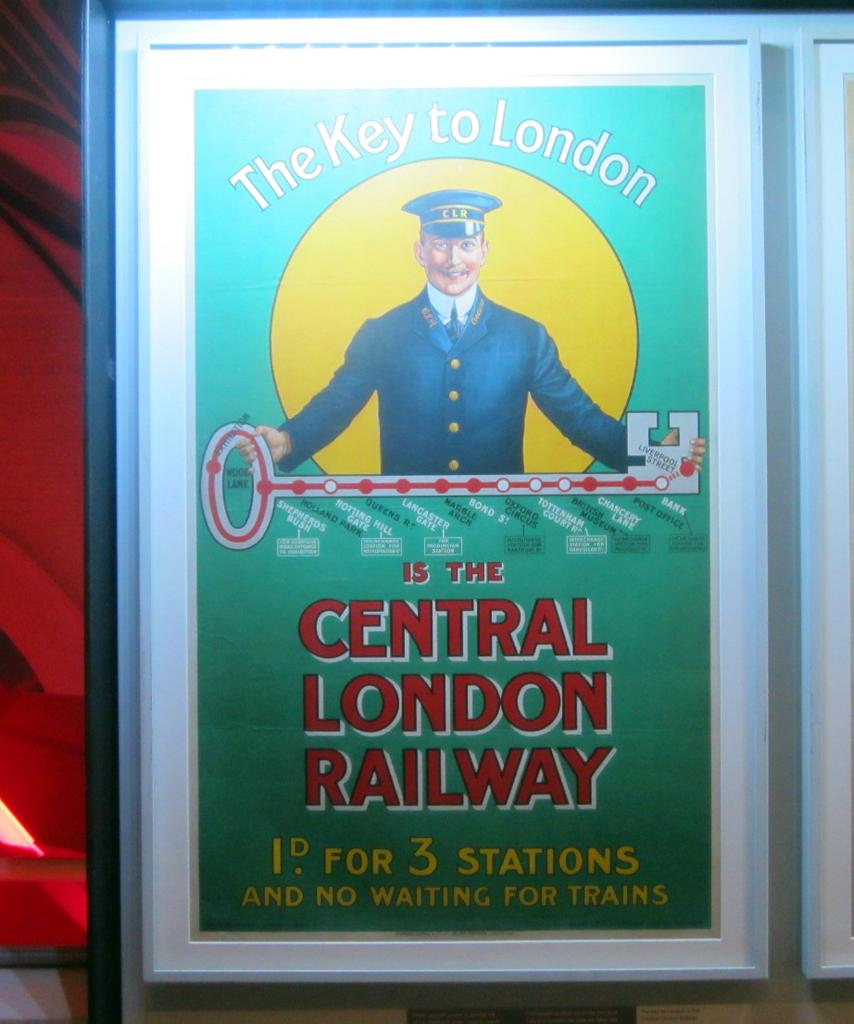What is the "key to london"?
Offer a very short reply. The central london railway. What city is this from?
Ensure brevity in your answer.  London. 